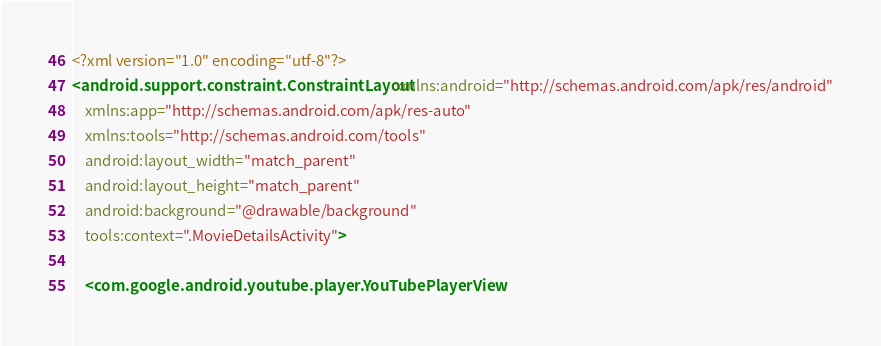Convert code to text. <code><loc_0><loc_0><loc_500><loc_500><_XML_><?xml version="1.0" encoding="utf-8"?>
<android.support.constraint.ConstraintLayout xmlns:android="http://schemas.android.com/apk/res/android"
    xmlns:app="http://schemas.android.com/apk/res-auto"
    xmlns:tools="http://schemas.android.com/tools"
    android:layout_width="match_parent"
    android:layout_height="match_parent"
    android:background="@drawable/background"
    tools:context=".MovieDetailsActivity">

    <com.google.android.youtube.player.YouTubePlayerView</code> 